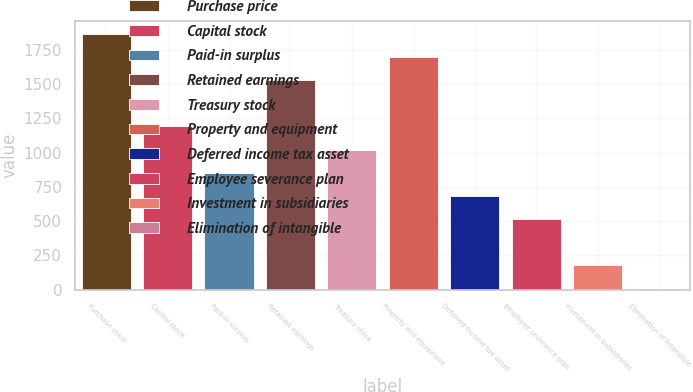Convert chart to OTSL. <chart><loc_0><loc_0><loc_500><loc_500><bar_chart><fcel>Purchase price<fcel>Capital stock<fcel>Paid-in surplus<fcel>Retained earnings<fcel>Treasury stock<fcel>Property and equipment<fcel>Deferred income tax asset<fcel>Employee severance plan<fcel>Investment in subsidiaries<fcel>Elimination of intangible<nl><fcel>1869.3<fcel>1192.1<fcel>853.5<fcel>1530.7<fcel>1022.8<fcel>1700<fcel>684.2<fcel>514.9<fcel>176.3<fcel>7<nl></chart> 